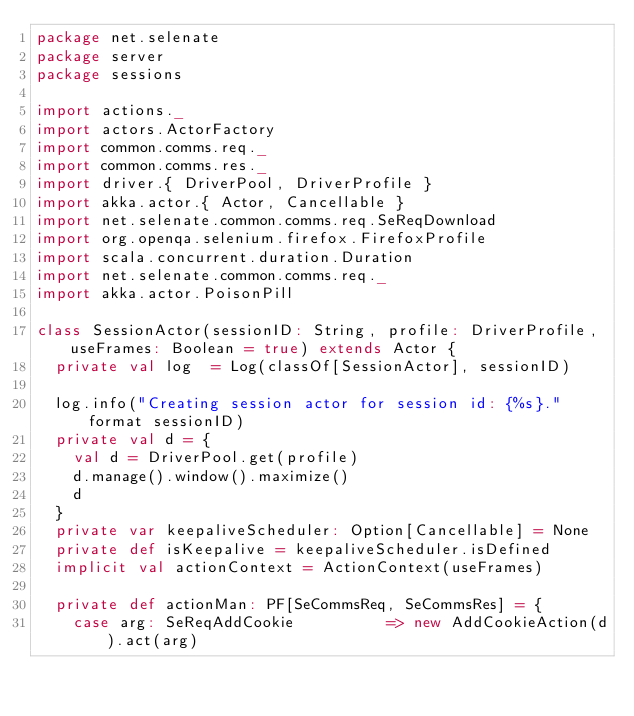Convert code to text. <code><loc_0><loc_0><loc_500><loc_500><_Scala_>package net.selenate
package server
package sessions

import actions._
import actors.ActorFactory
import common.comms.req._
import common.comms.res._
import driver.{ DriverPool, DriverProfile }
import akka.actor.{ Actor, Cancellable }
import net.selenate.common.comms.req.SeReqDownload
import org.openqa.selenium.firefox.FirefoxProfile
import scala.concurrent.duration.Duration
import net.selenate.common.comms.req._
import akka.actor.PoisonPill

class SessionActor(sessionID: String, profile: DriverProfile, useFrames: Boolean = true) extends Actor {
  private val log  = Log(classOf[SessionActor], sessionID)

  log.info("Creating session actor for session id: {%s}." format sessionID)
  private val d = {
    val d = DriverPool.get(profile)
    d.manage().window().maximize()
    d
  }
  private var keepaliveScheduler: Option[Cancellable] = None
  private def isKeepalive = keepaliveScheduler.isDefined
  implicit val actionContext = ActionContext(useFrames)

  private def actionMan: PF[SeCommsReq, SeCommsRes] = {
    case arg: SeReqAddCookie          => new AddCookieAction(d).act(arg)</code> 